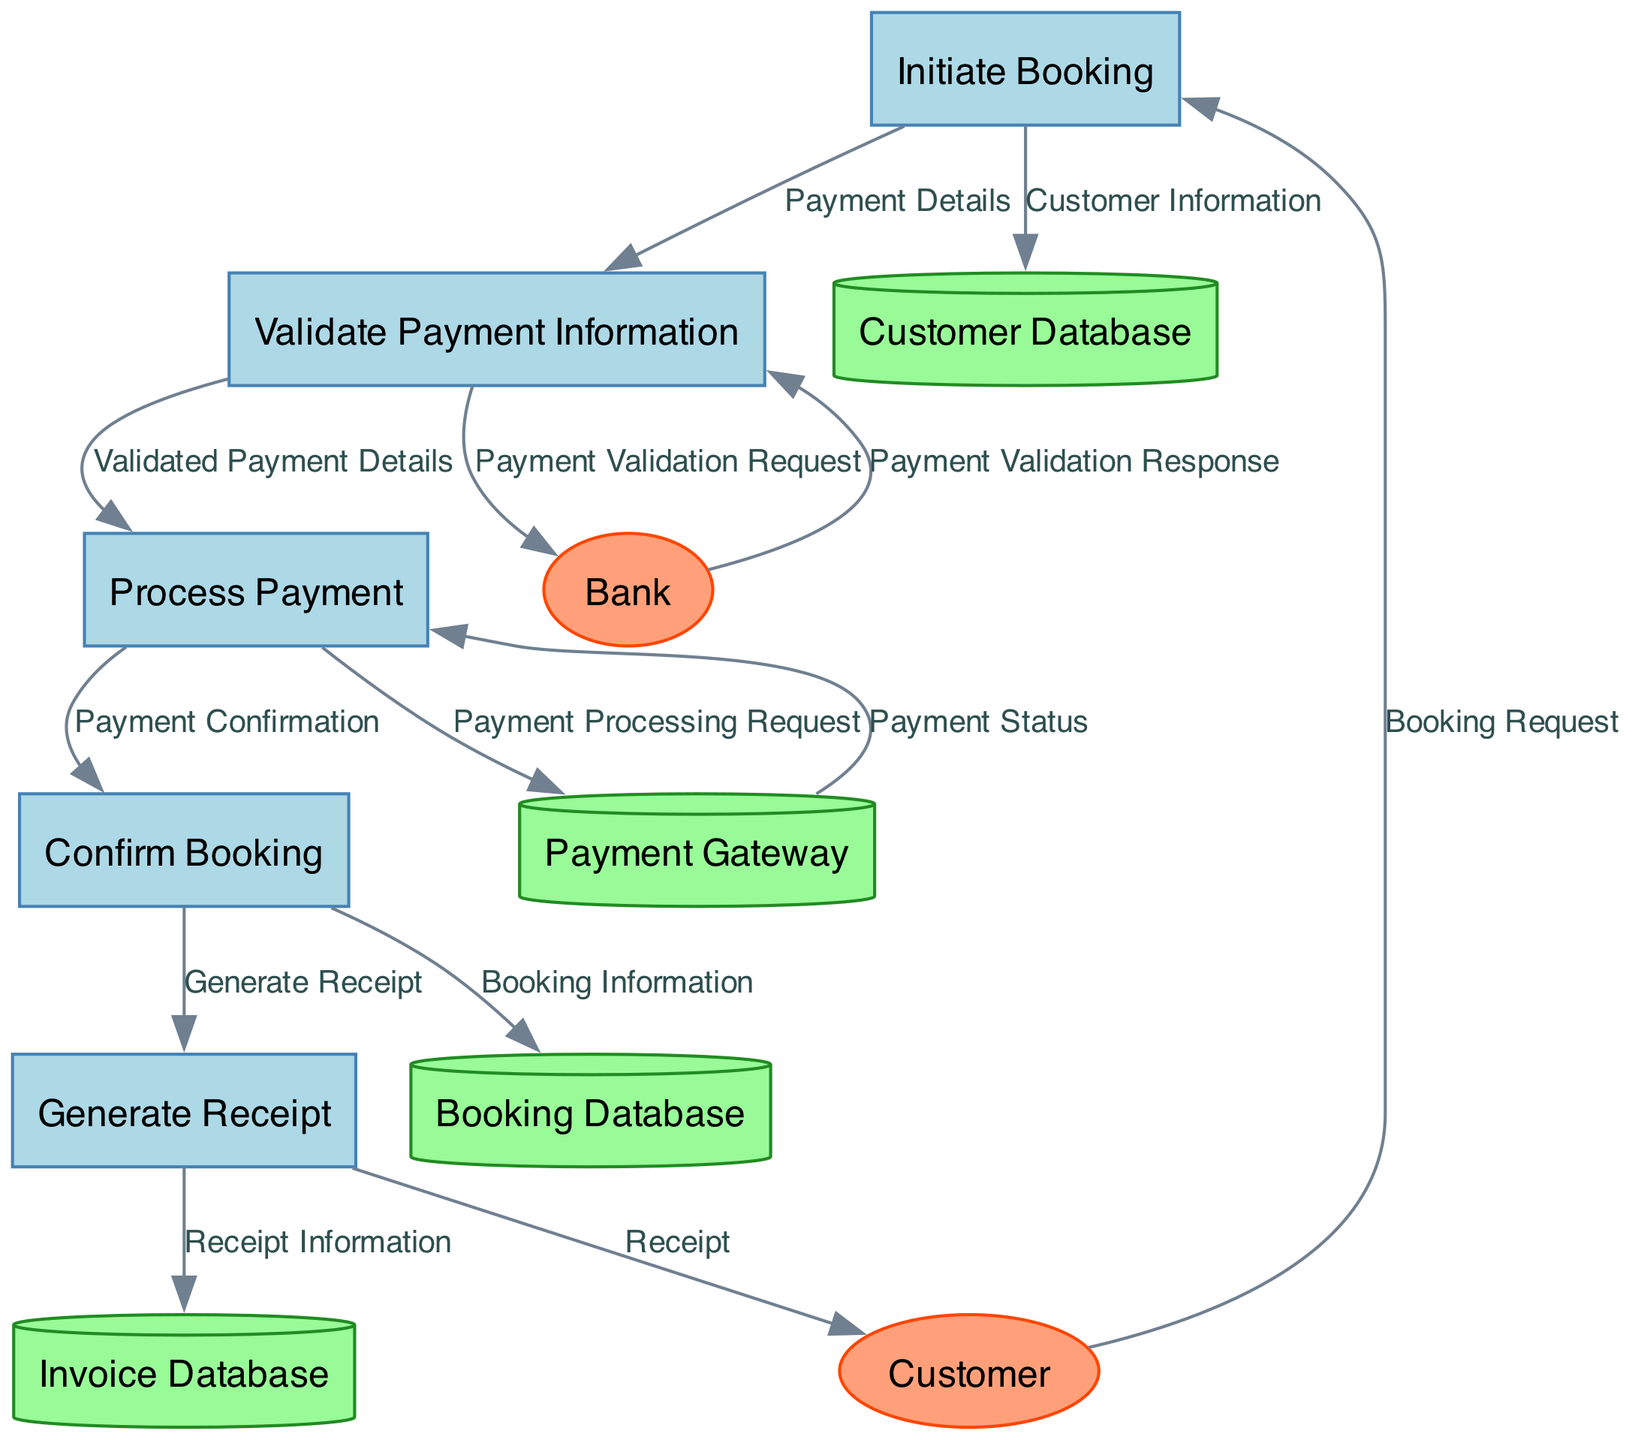What is the first process in the diagram? The first process listed is "Initiate Booking," which is represented as P1 in the diagram. It is the starting point of the booking workflow.
Answer: Initiate Booking How many processes are in the diagram? The diagram includes a total of five processes: Initiate Booking, Validate Payment Information, Process Payment, Confirm Booking, and Generate Receipt.
Answer: Five What type of entity is "Customer" classified as? "Customer" is classified as an external entity in the diagram, indicating it interacts with the internal processes. This is shown by its ellipse shape.
Answer: External Entity What is the destination of the "Payment Status" flow? The "Payment Status" flow originates from the Payment Gateway data store and flows into the "Process Payment" process.
Answer: Process Payment Which data store is related to the receipt generation? The data store related to the receipt generation process is the "Invoice Database," indicated by the data flow from "Generate Receipt" to "Invoice Database."
Answer: Invoice Database What flows into the "Validate Payment Information" process? The inputs flowing into the "Validate Payment Information" process include "Payment Details" from the "Initiate Booking" process and a "Payment Validation Response" from the "Bank" external entity after a validation request.
Answer: Payment Details, Payment Validation Response How many external entities are depicted in the diagram? The diagram showcases two external entities: the Customer and the Bank. These entities represent outside interactions associated with the payment processing system.
Answer: Two What is the last process that generates a document for the customer? The last process that generates a document for the customer is "Generate Receipt," which produces the receipt that is sent to the Customer.
Answer: Generate Receipt What does the "Payment Confirmation" flow indicate? The "Payment Confirmation" flow indicates that the payment has been successfully processed and is sent from the "Process Payment" process to the "Confirm Booking" process, validating the booking.
Answer: Booking Confirmation 